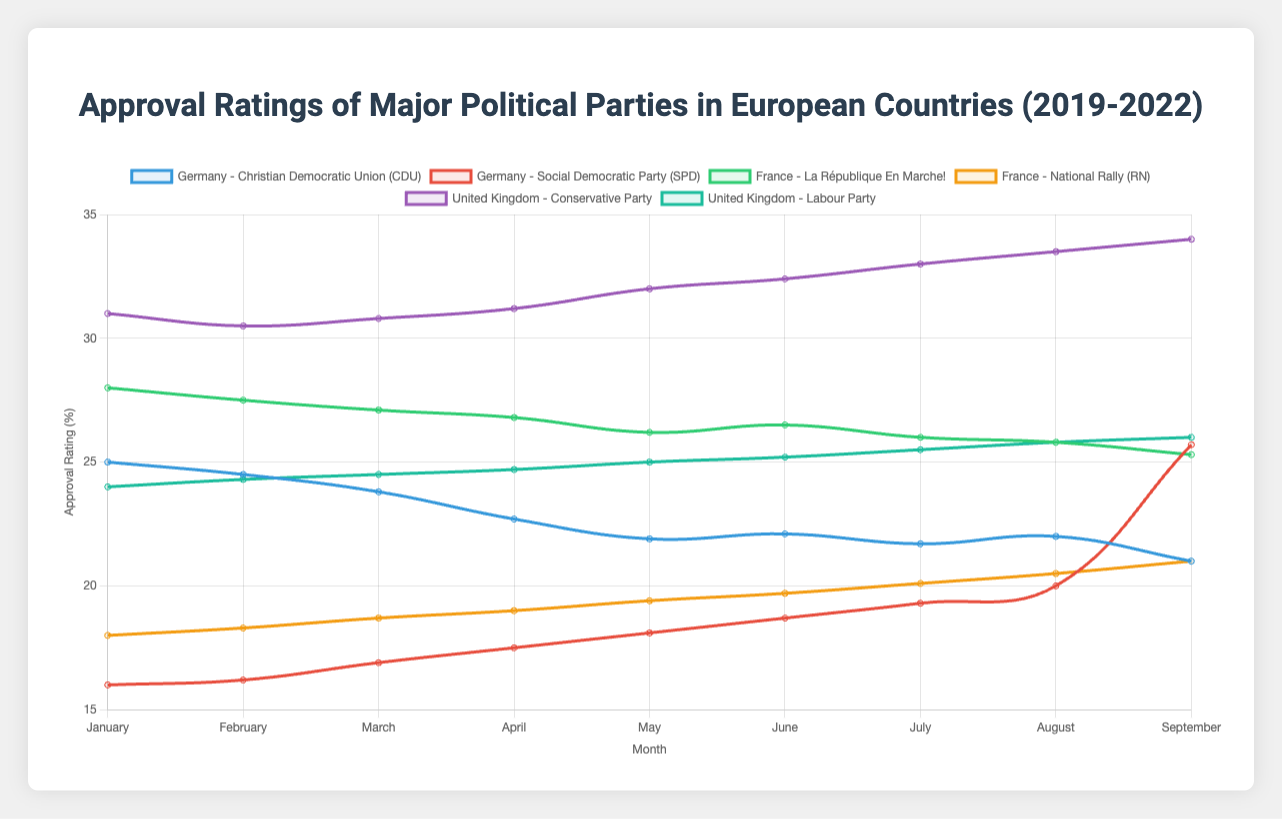Which party in Germany saw the largest increase in approval ratings between January and September? To determine this, subtract the January rating from the September rating for both parties in Germany, then compare the differences. CDU: 21.0 - 25.0 = -4.0. SPD: 25.7 - 16.0 = 9.7. SPD had the largest increase (9.7).
Answer: SPD How did the approval rating of the National Rally in France change from July to August? Look at the approval ratings for the National Rally in France. In July, the rating was 20.1 and in August, it was 20.5. The change is 20.5 - 20.1 = 0.4.
Answer: Increased by 0.4 Which party had the highest approval rating in September across all countries? When examining the September ratings across all parties and countries, the Conservative Party in the UK had the highest approval rating at 34.0.
Answer: Conservative Party What is the average approval rating of La République En Marche! in France for the year? Sum the approval ratings from January to September and divide by the number of months: (28.0 + 27.5 + 27.1 + 26.8 + 26.2 + 26.5 + 26.0 + 25.8 + 25.3) / 9 = 26.48.
Answer: 26.48 Compare the trends of the Labour Party and Conservative Party in the UK over the election cycle. Which party's ratings were more stable? Observing the line patterns, the Conservative Party's ratings steadily increased from 31.0 to 34.0, while Labour's ratings increased from 24.0 to 26.0. The Labour Party had less fluctuation (2.0 vs. 3.0).
Answer: Labour Party Which German party had a decreasing trend in approval ratings from January to May, and what was the total decrease? For CDU, January to May was 25.0 to 21.9. (25.0 - 24.5 - 23.8 - 22.7 - 21.9)=-3.1. For SPD, it was 16.0 to 18.1. CDU had a total decrease of 3.1 from January to May.
Answer: CDU, -3.1 What was the difference in approval ratings between CDU and SPD in Germany in March? CDU had a rating of 23.8 and SPD had a rating of 16.9 in March. The difference is 23.8 - 16.9 = 6.9.
Answer: 6.9 Which party's approval rating decreased the most in any single month across all countries? The CDU in Germany experienced the largest decrease from March to April, from 23.8 to 22.7, a drop of 23.8 - 22.7 = 1.1.
Answer: CDU What is the overall trend for the National Rally (RN) in France during the election cycle? The National Rally started at 18.0 in January and ended at 21.0 in September, showing a consistent increasing trend.
Answer: Increasing What was the combined approval rating of the Labour Party and Conservative Party in the UK in June? Sum the approval ratings of Labour and Conservative parties in June: 25.2 (Labour) + 32.4 (Conservative) = 57.6.
Answer: 57.6 